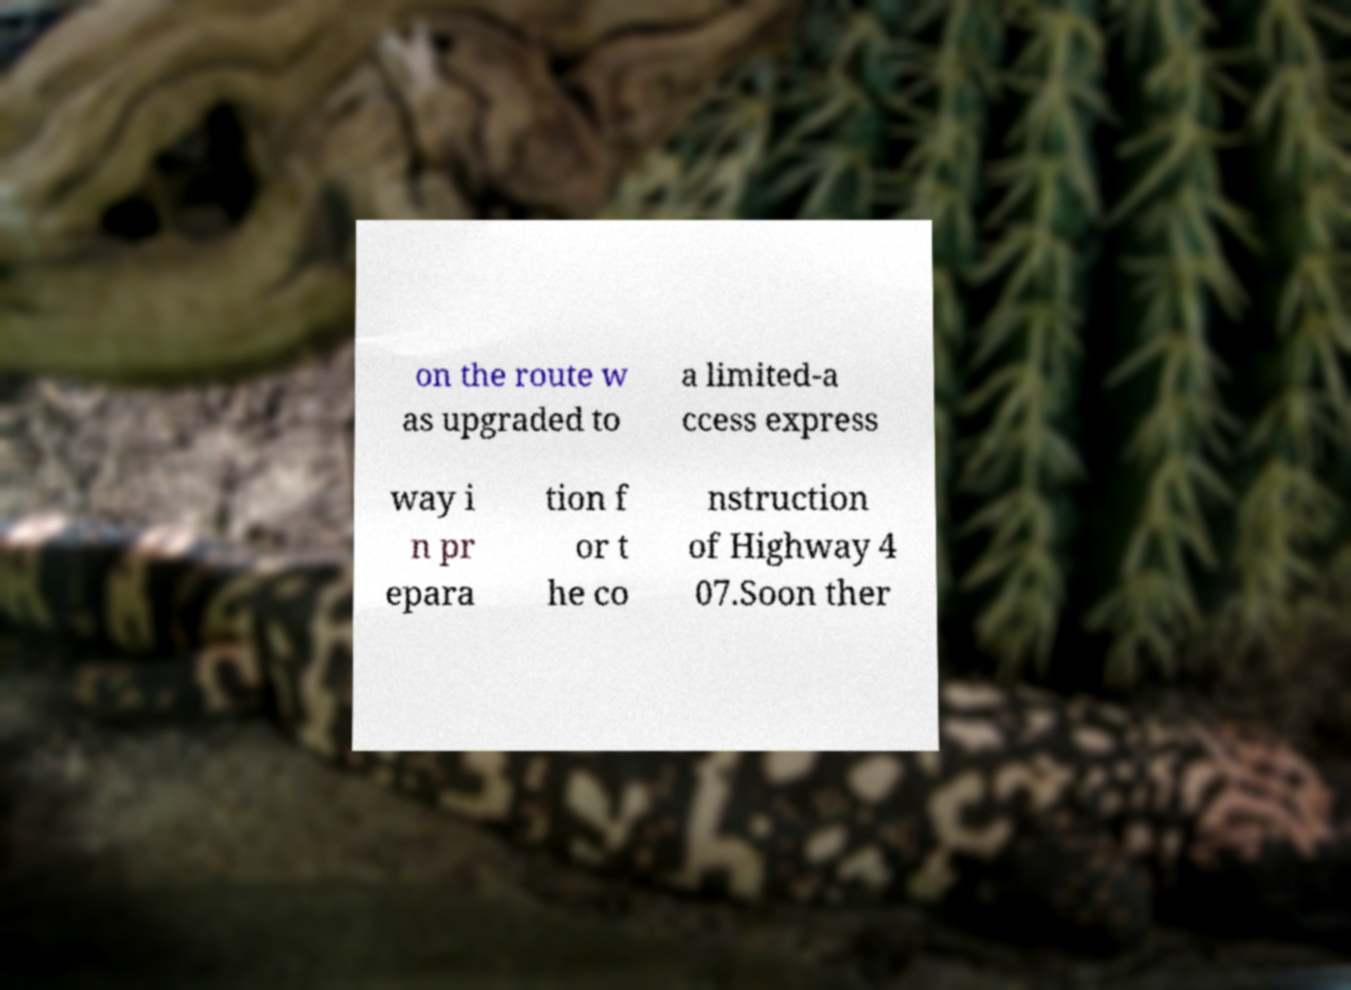Please read and relay the text visible in this image. What does it say? on the route w as upgraded to a limited-a ccess express way i n pr epara tion f or t he co nstruction of Highway 4 07.Soon ther 